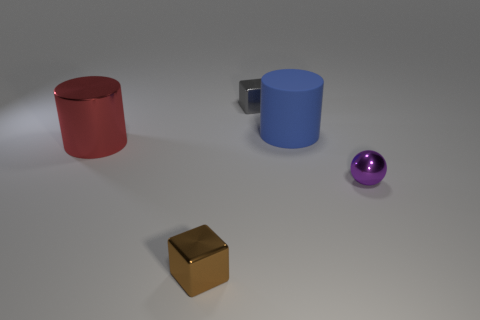Add 3 metallic things. How many objects exist? 8 Subtract all red cylinders. How many cylinders are left? 1 Subtract 1 cylinders. How many cylinders are left? 1 Subtract all spheres. How many objects are left? 4 Subtract 0 gray balls. How many objects are left? 5 Subtract all brown cubes. Subtract all red cylinders. How many cubes are left? 1 Subtract all yellow blocks. How many red cylinders are left? 1 Subtract all small balls. Subtract all small objects. How many objects are left? 1 Add 5 big blue rubber cylinders. How many big blue rubber cylinders are left? 6 Add 1 tiny red blocks. How many tiny red blocks exist? 1 